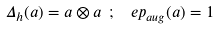Convert formula to latex. <formula><loc_0><loc_0><loc_500><loc_500>\Delta _ { h } ( a ) = a \otimes a \ ; \ \ e p _ { a u g } ( a ) = 1</formula> 